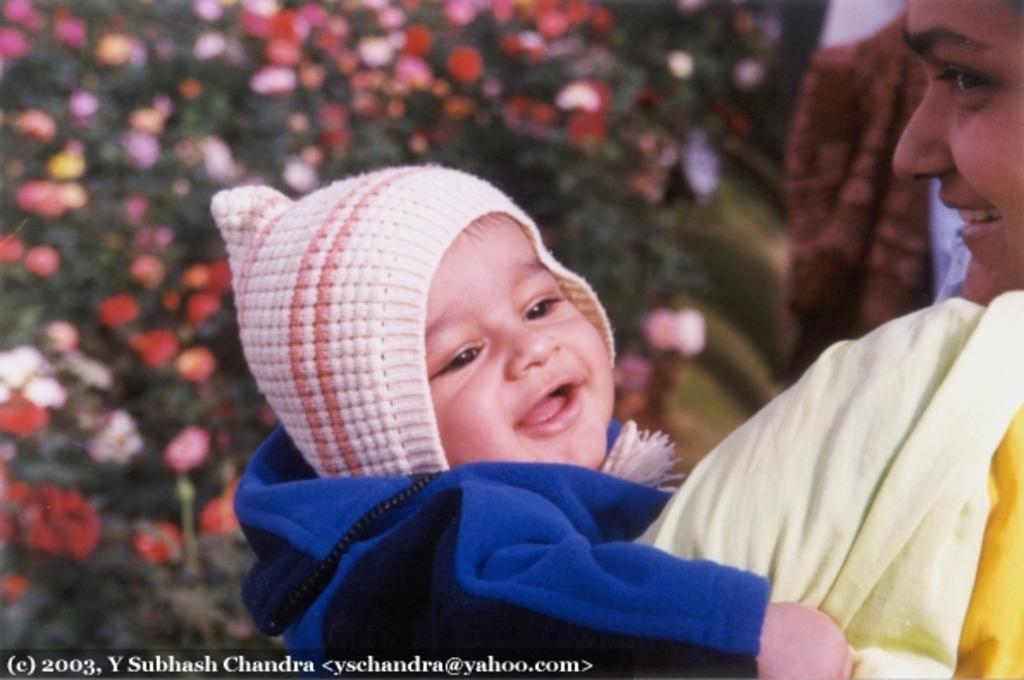Can you describe this image briefly? In this image there is a woman holding a baby in her arms. The baby is wearing a cap. Background there are plants having flowers and leaves. Bottom of the image there is some text. 